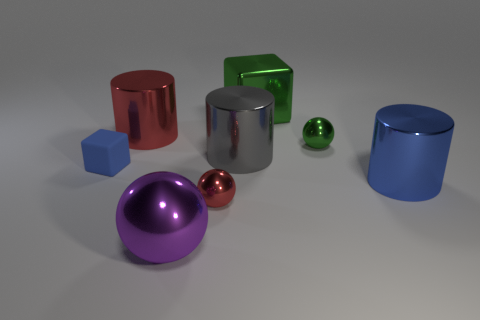Add 1 large objects. How many objects exist? 9 Subtract all small balls. How many balls are left? 1 Subtract all purple balls. How many balls are left? 2 Add 3 red cubes. How many red cubes exist? 3 Subtract 0 brown blocks. How many objects are left? 8 Subtract all balls. How many objects are left? 5 Subtract 1 blocks. How many blocks are left? 1 Subtract all red cylinders. Subtract all green spheres. How many cylinders are left? 2 Subtract all purple cubes. How many blue cylinders are left? 1 Subtract all gray cylinders. Subtract all metal blocks. How many objects are left? 6 